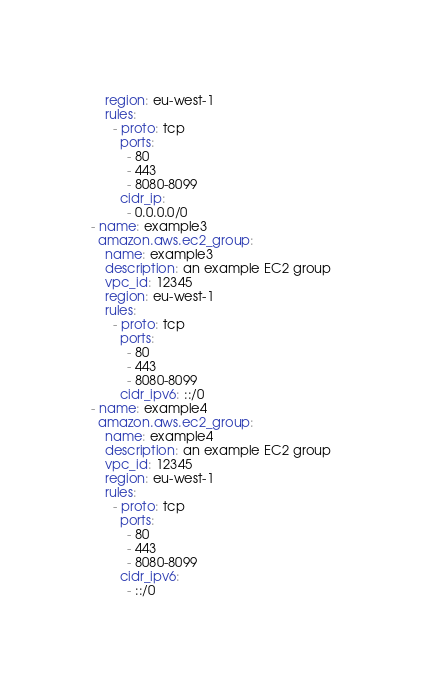<code> <loc_0><loc_0><loc_500><loc_500><_YAML_>    region: eu-west-1
    rules:
      - proto: tcp
        ports:
          - 80
          - 443
          - 8080-8099
        cidr_ip:
          - 0.0.0.0/0
- name: example3
  amazon.aws.ec2_group:
    name: example3
    description: an example EC2 group
    vpc_id: 12345
    region: eu-west-1
    rules:
      - proto: tcp
        ports:
          - 80
          - 443
          - 8080-8099
        cidr_ipv6: ::/0
- name: example4
  amazon.aws.ec2_group:
    name: example4
    description: an example EC2 group
    vpc_id: 12345
    region: eu-west-1
    rules:
      - proto: tcp
        ports:
          - 80
          - 443
          - 8080-8099
        cidr_ipv6:
          - ::/0</code> 